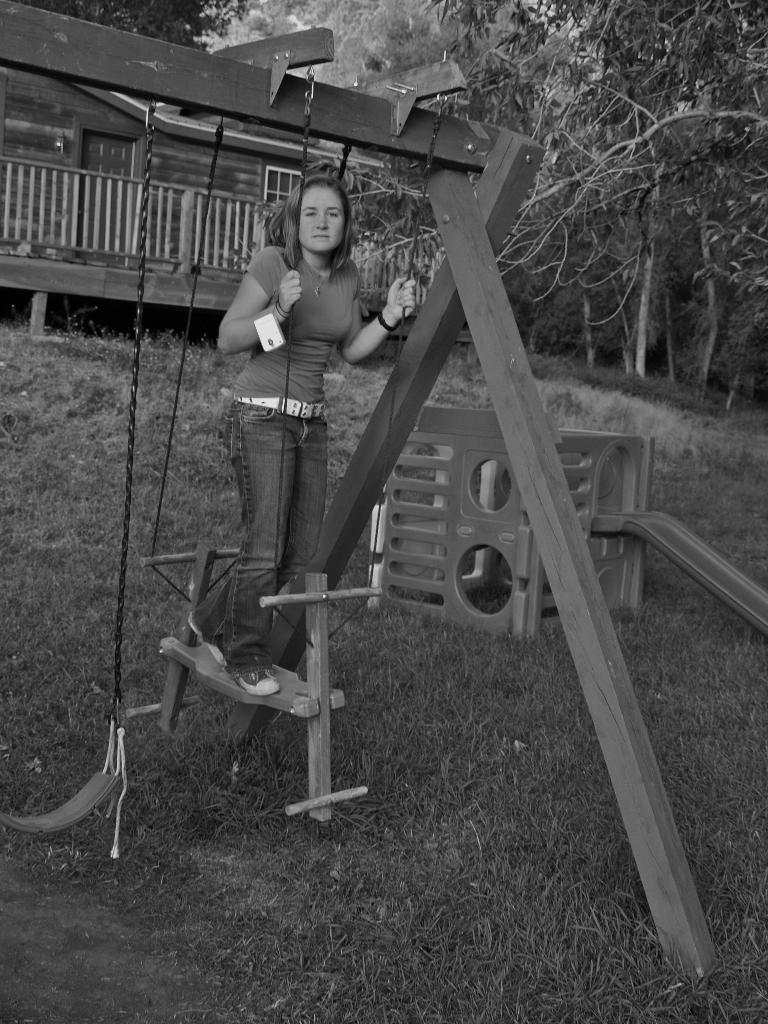Describe this image in one or two sentences. In the image I can see a lady on the wooden thing and to the side there is a swing and also I can see a house, trees and some other things around. 